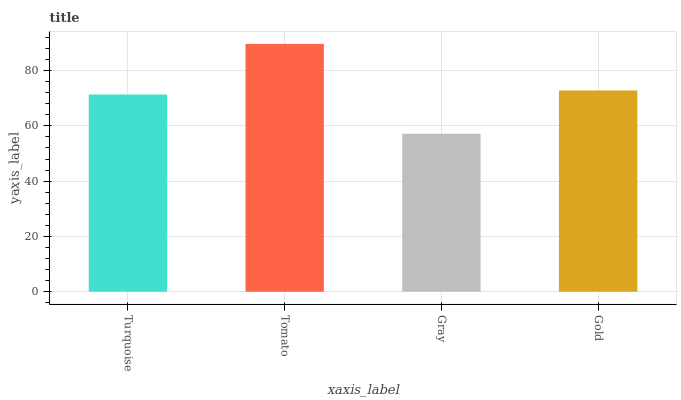Is Gray the minimum?
Answer yes or no. Yes. Is Tomato the maximum?
Answer yes or no. Yes. Is Tomato the minimum?
Answer yes or no. No. Is Gray the maximum?
Answer yes or no. No. Is Tomato greater than Gray?
Answer yes or no. Yes. Is Gray less than Tomato?
Answer yes or no. Yes. Is Gray greater than Tomato?
Answer yes or no. No. Is Tomato less than Gray?
Answer yes or no. No. Is Gold the high median?
Answer yes or no. Yes. Is Turquoise the low median?
Answer yes or no. Yes. Is Gray the high median?
Answer yes or no. No. Is Tomato the low median?
Answer yes or no. No. 